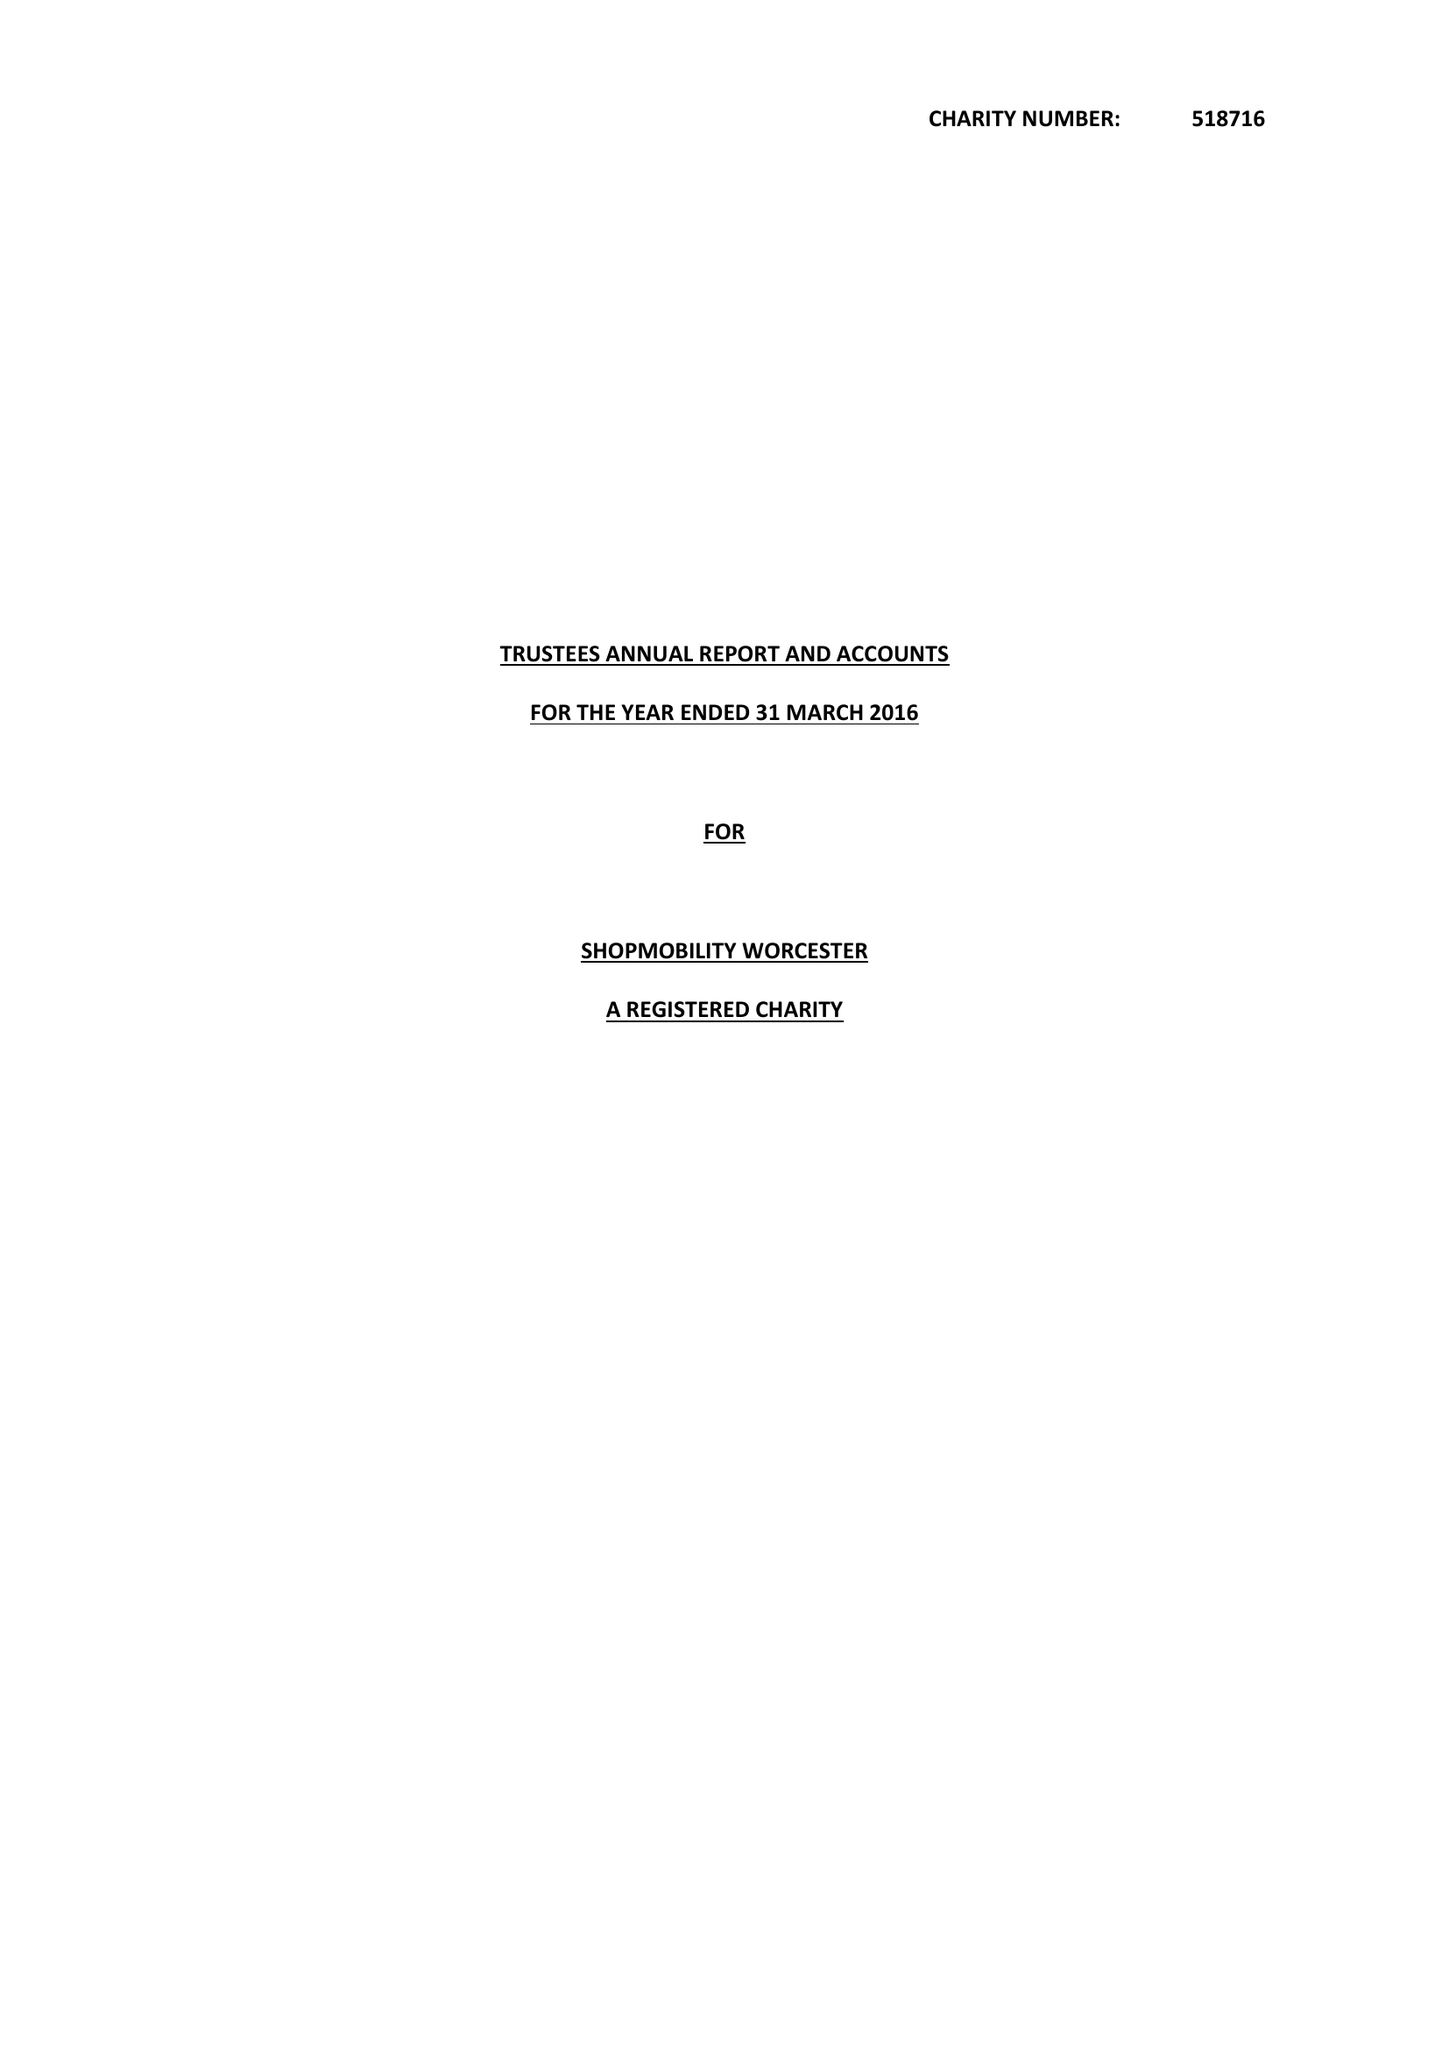What is the value for the address__post_town?
Answer the question using a single word or phrase. WORCESTER 